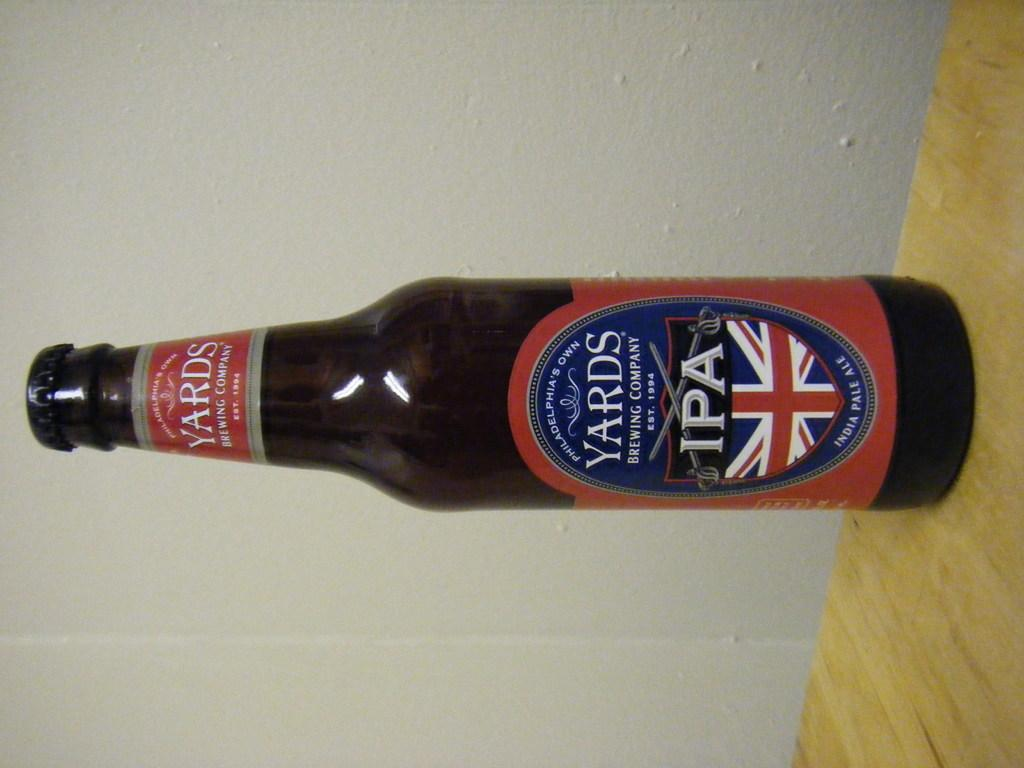<image>
Create a compact narrative representing the image presented. A British beer names Yards has a blue, red and white label with a flag design. 